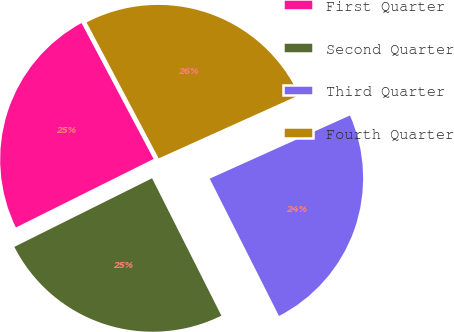Convert chart to OTSL. <chart><loc_0><loc_0><loc_500><loc_500><pie_chart><fcel>First Quarter<fcel>Second Quarter<fcel>Third Quarter<fcel>Fourth Quarter<nl><fcel>24.59%<fcel>25.08%<fcel>24.3%<fcel>26.02%<nl></chart> 